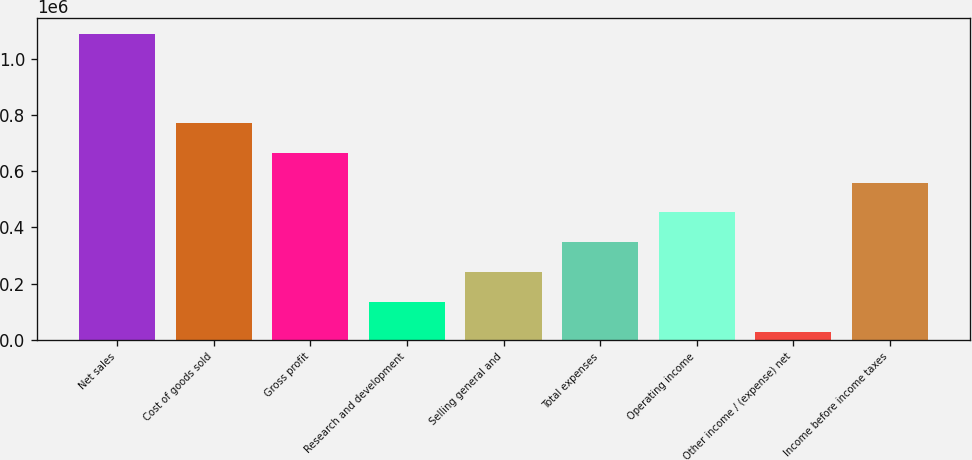Convert chart to OTSL. <chart><loc_0><loc_0><loc_500><loc_500><bar_chart><fcel>Net sales<fcel>Cost of goods sold<fcel>Gross profit<fcel>Research and development<fcel>Selling general and<fcel>Total expenses<fcel>Operating income<fcel>Other income / (expense) net<fcel>Income before income taxes<nl><fcel>1.08909e+06<fcel>771206<fcel>665243<fcel>135430<fcel>241393<fcel>347356<fcel>453318<fcel>29468<fcel>559280<nl></chart> 